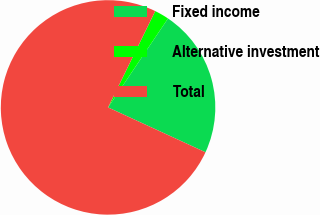Convert chart. <chart><loc_0><loc_0><loc_500><loc_500><pie_chart><fcel>Fixed income<fcel>Alternative investment<fcel>Total<nl><fcel>22.43%<fcel>2.19%<fcel>75.37%<nl></chart> 